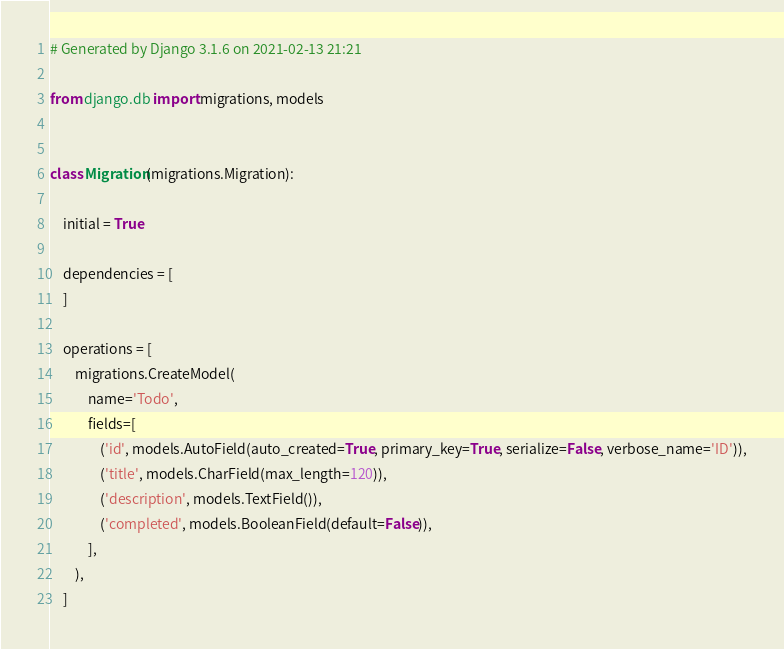Convert code to text. <code><loc_0><loc_0><loc_500><loc_500><_Python_># Generated by Django 3.1.6 on 2021-02-13 21:21

from django.db import migrations, models


class Migration(migrations.Migration):

    initial = True

    dependencies = [
    ]

    operations = [
        migrations.CreateModel(
            name='Todo',
            fields=[
                ('id', models.AutoField(auto_created=True, primary_key=True, serialize=False, verbose_name='ID')),
                ('title', models.CharField(max_length=120)),
                ('description', models.TextField()),
                ('completed', models.BooleanField(default=False)),
            ],
        ),
    ]
</code> 